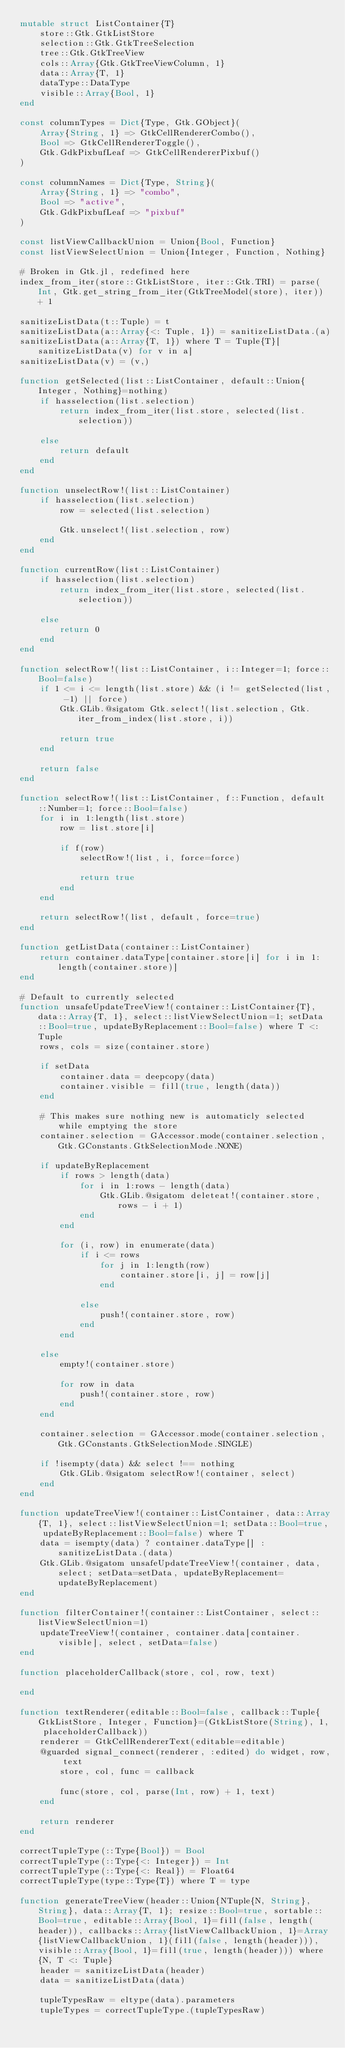Convert code to text. <code><loc_0><loc_0><loc_500><loc_500><_Julia_>mutable struct ListContainer{T}
    store::Gtk.GtkListStore
    selection::Gtk.GtkTreeSelection
    tree::Gtk.GtkTreeView
    cols::Array{Gtk.GtkTreeViewColumn, 1}
    data::Array{T, 1}
    dataType::DataType
    visible::Array{Bool, 1}
end

const columnTypes = Dict{Type, Gtk.GObject}(
    Array{String, 1} => GtkCellRendererCombo(),
    Bool => GtkCellRendererToggle(),
    Gtk.GdkPixbufLeaf => GtkCellRendererPixbuf()
)

const columnNames = Dict{Type, String}(
    Array{String, 1} => "combo",
    Bool => "active",
    Gtk.GdkPixbufLeaf => "pixbuf"
)

const listViewCallbackUnion = Union{Bool, Function}
const listViewSelectUnion = Union{Integer, Function, Nothing}

# Broken in Gtk.jl, redefined here
index_from_iter(store::GtkListStore, iter::Gtk.TRI) = parse(Int, Gtk.get_string_from_iter(GtkTreeModel(store), iter)) + 1

sanitizeListData(t::Tuple) = t
sanitizeListData(a::Array{<: Tuple, 1}) = sanitizeListData.(a)
sanitizeListData(a::Array{T, 1}) where T = Tuple{T}[sanitizeListData(v) for v in a]
sanitizeListData(v) = (v,)

function getSelected(list::ListContainer, default::Union{Integer, Nothing}=nothing)
    if hasselection(list.selection)
        return index_from_iter(list.store, selected(list.selection))

    else
        return default
    end
end

function unselectRow!(list::ListContainer)
    if hasselection(list.selection)
        row = selected(list.selection)

        Gtk.unselect!(list.selection, row)
    end
end

function currentRow(list::ListContainer)
    if hasselection(list.selection)
        return index_from_iter(list.store, selected(list.selection))
    
    else
        return 0
    end
end

function selectRow!(list::ListContainer, i::Integer=1; force::Bool=false)
    if 1 <= i <= length(list.store) && (i != getSelected(list, -1) || force)
        Gtk.GLib.@sigatom Gtk.select!(list.selection, Gtk.iter_from_index(list.store, i))

        return true
    end

    return false
end

function selectRow!(list::ListContainer, f::Function, default::Number=1; force::Bool=false)
    for i in 1:length(list.store)
        row = list.store[i]

        if f(row)
            selectRow!(list, i, force=force)

            return true
        end
    end

    return selectRow!(list, default, force=true)
end

function getListData(container::ListContainer)
    return container.dataType[container.store[i] for i in 1:length(container.store)]
end

# Default to currently selected
function unsafeUpdateTreeView!(container::ListContainer{T}, data::Array{T, 1}, select::listViewSelectUnion=1; setData::Bool=true, updateByReplacement::Bool=false) where T <: Tuple
    rows, cols = size(container.store)

    if setData
        container.data = deepcopy(data)
        container.visible = fill(true, length(data))
    end

    # This makes sure nothing new is automaticly selected while emptying the store
    container.selection = GAccessor.mode(container.selection, Gtk.GConstants.GtkSelectionMode.NONE)

    if updateByReplacement
        if rows > length(data)
            for i in 1:rows - length(data)
                Gtk.GLib.@sigatom deleteat!(container.store, rows - i + 1)
            end
        end

        for (i, row) in enumerate(data)
            if i <= rows
                for j in 1:length(row)
                    container.store[i, j] = row[j]
                end

            else
                push!(container.store, row)
            end
        end

    else
        empty!(container.store)

        for row in data
            push!(container.store, row)
        end
    end

    container.selection = GAccessor.mode(container.selection, Gtk.GConstants.GtkSelectionMode.SINGLE)

    if !isempty(data) && select !== nothing
        Gtk.GLib.@sigatom selectRow!(container, select)
    end
end

function updateTreeView!(container::ListContainer, data::Array{T, 1}, select::listViewSelectUnion=1; setData::Bool=true, updateByReplacement::Bool=false) where T
    data = isempty(data) ? container.dataType[] : sanitizeListData.(data)
    Gtk.GLib.@sigatom unsafeUpdateTreeView!(container, data, select; setData=setData, updateByReplacement=updateByReplacement)
end

function filterContainer!(container::ListContainer, select::listViewSelectUnion=1)
    updateTreeView!(container, container.data[container.visible], select, setData=false)
end

function placeholderCallback(store, col, row, text)

end

function textRenderer(editable::Bool=false, callback::Tuple{GtkListStore, Integer, Function}=(GtkListStore(String), 1, placeholderCallback))
    renderer = GtkCellRendererText(editable=editable)
    @guarded signal_connect(renderer, :edited) do widget, row, text
        store, col, func = callback

        func(store, col, parse(Int, row) + 1, text)
    end

    return renderer
end

correctTupleType(::Type{Bool}) = Bool
correctTupleType(::Type{<: Integer}) = Int
correctTupleType(::Type{<: Real}) = Float64
correctTupleType(type::Type{T}) where T = type

function generateTreeView(header::Union{NTuple{N, String}, String}, data::Array{T, 1}; resize::Bool=true, sortable::Bool=true, editable::Array{Bool, 1}=fill(false, length(header)), callbacks::Array{listViewCallbackUnion, 1}=Array{listViewCallbackUnion, 1}(fill(false, length(header))), visible::Array{Bool, 1}=fill(true, length(header))) where {N, T <: Tuple}
    header = sanitizeListData(header)
    data = sanitizeListData(data)

    tupleTypesRaw = eltype(data).parameters
    tupleTypes = correctTupleType.(tupleTypesRaw)</code> 